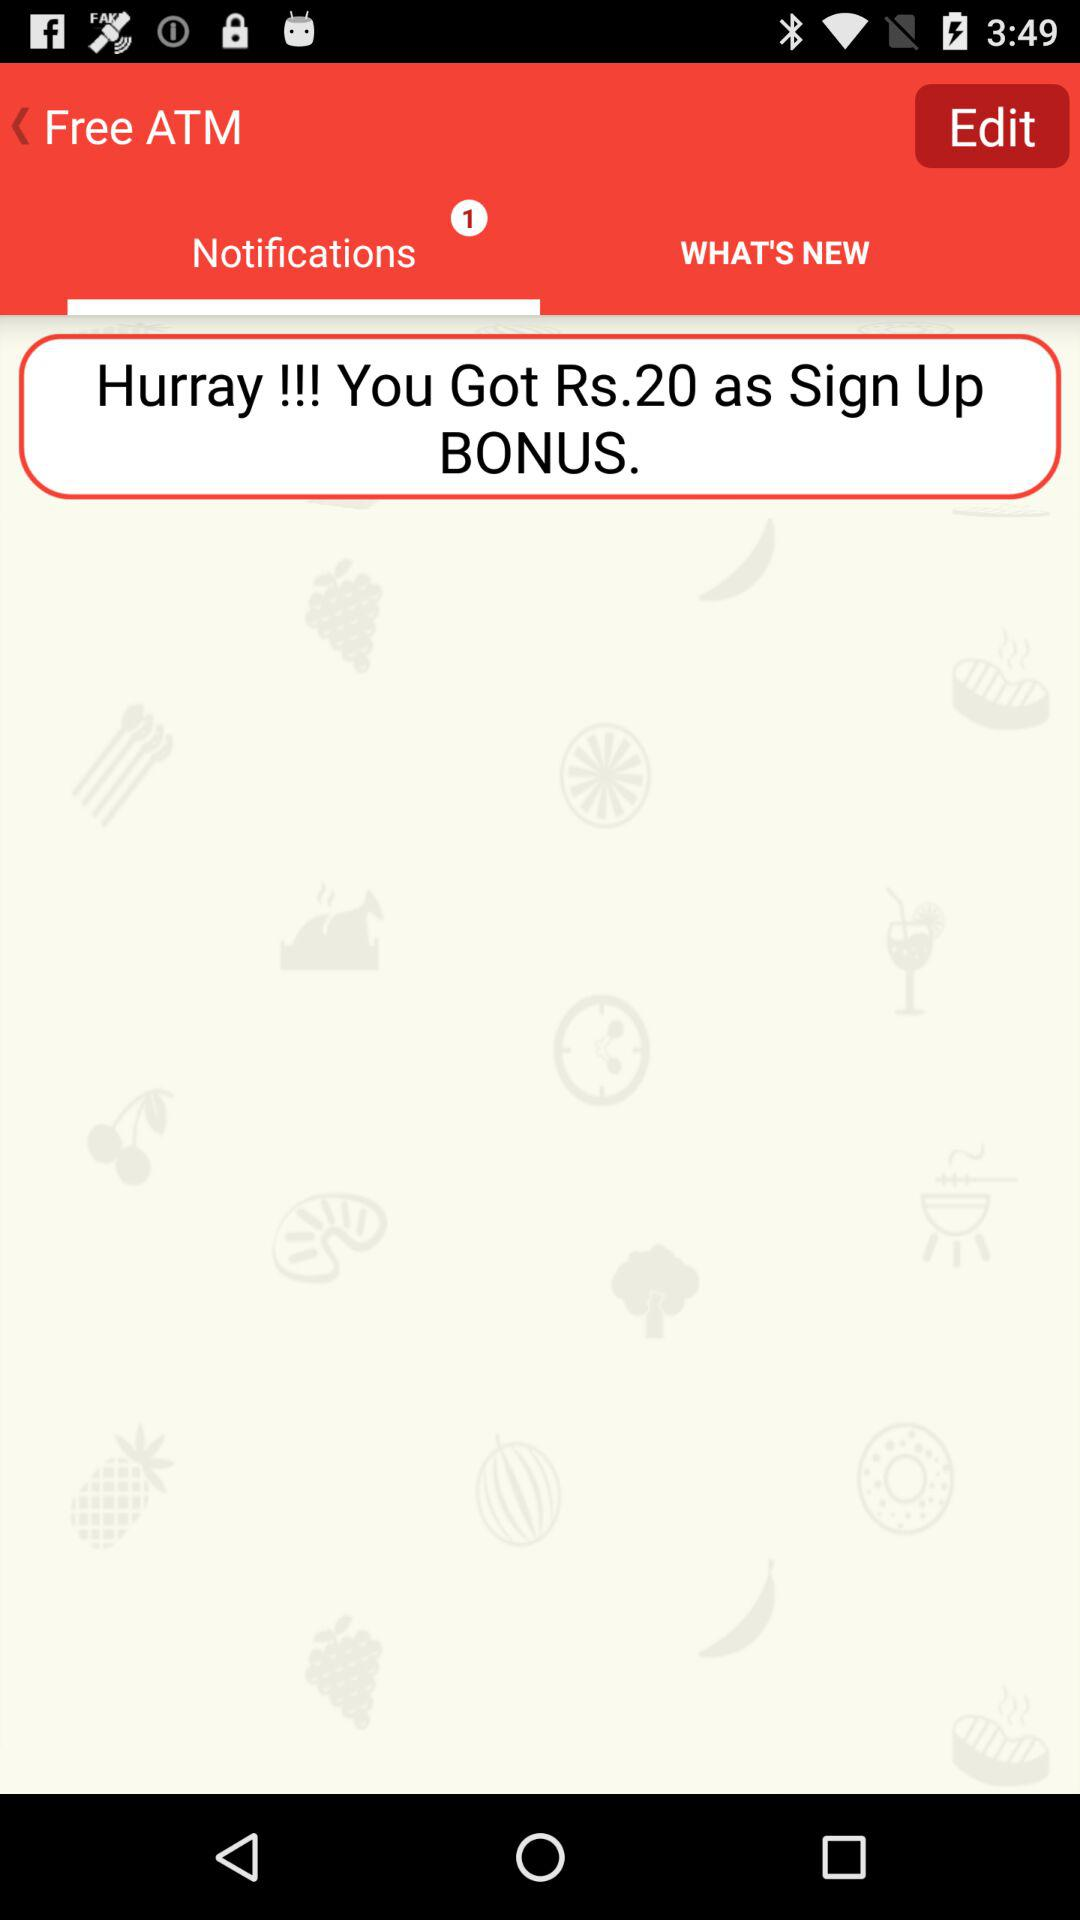What amount have I gotten as a sign-up bonus? You have gotten 20 rupees as a sign-up bonus. 